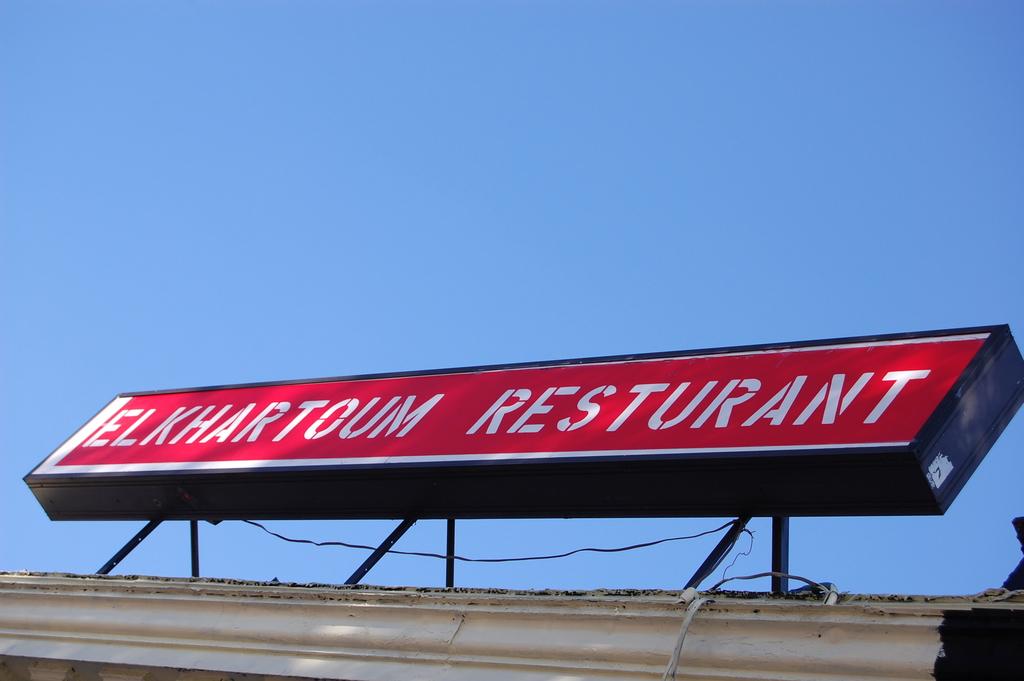Is elkharton a resturant?
Provide a succinct answer. Yes. 